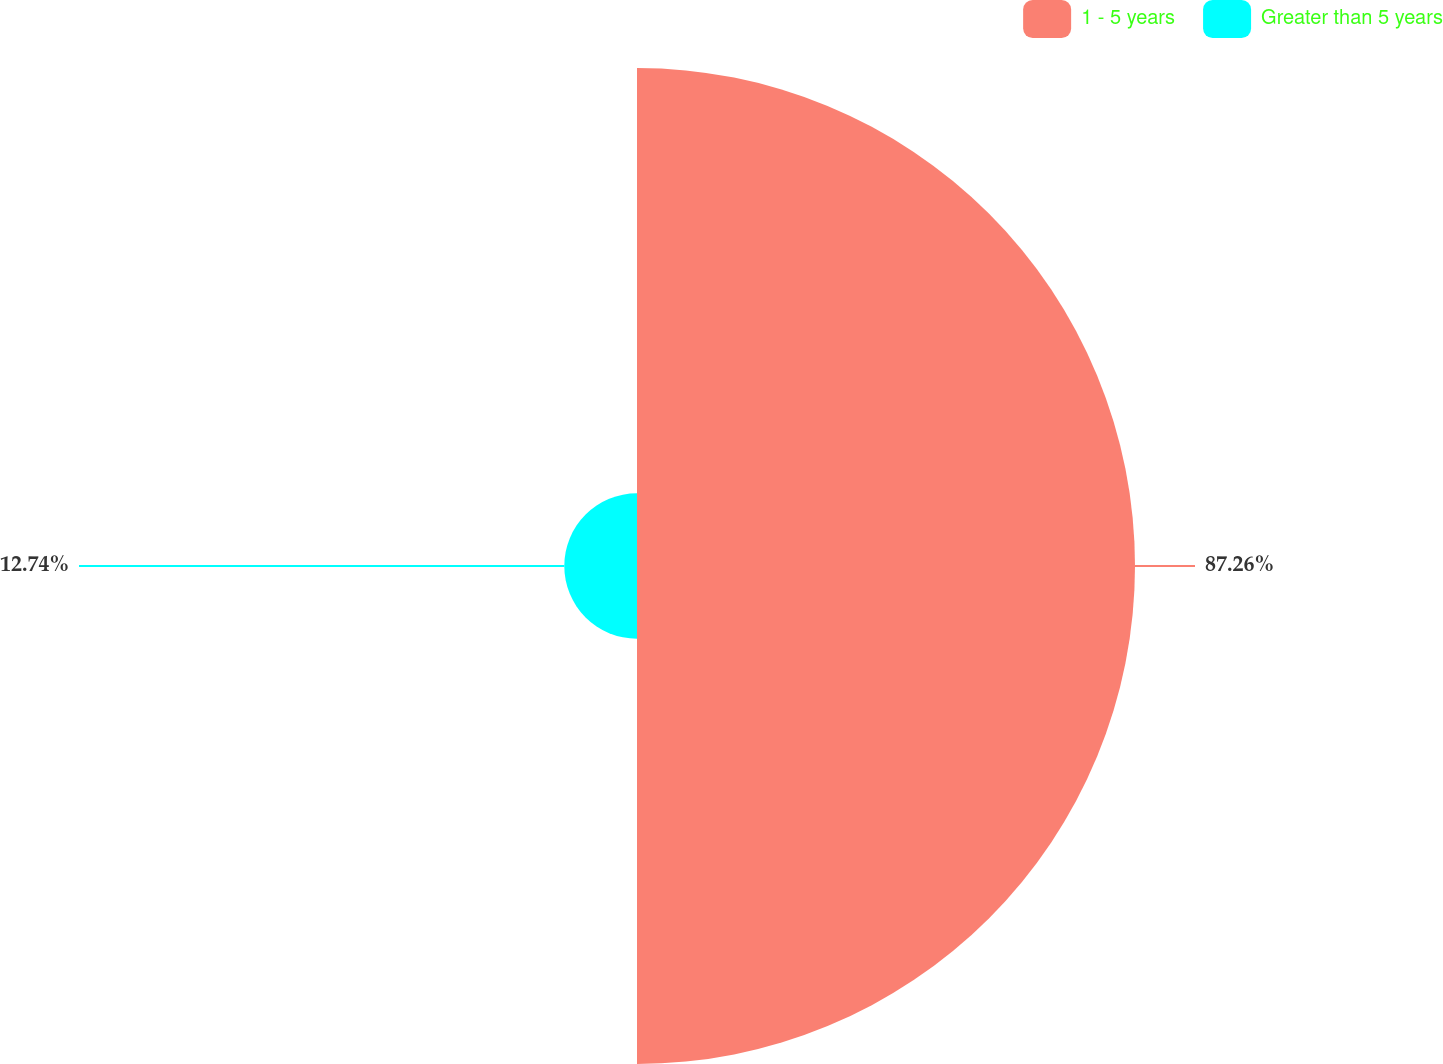Convert chart. <chart><loc_0><loc_0><loc_500><loc_500><pie_chart><fcel>1 - 5 years<fcel>Greater than 5 years<nl><fcel>87.26%<fcel>12.74%<nl></chart> 